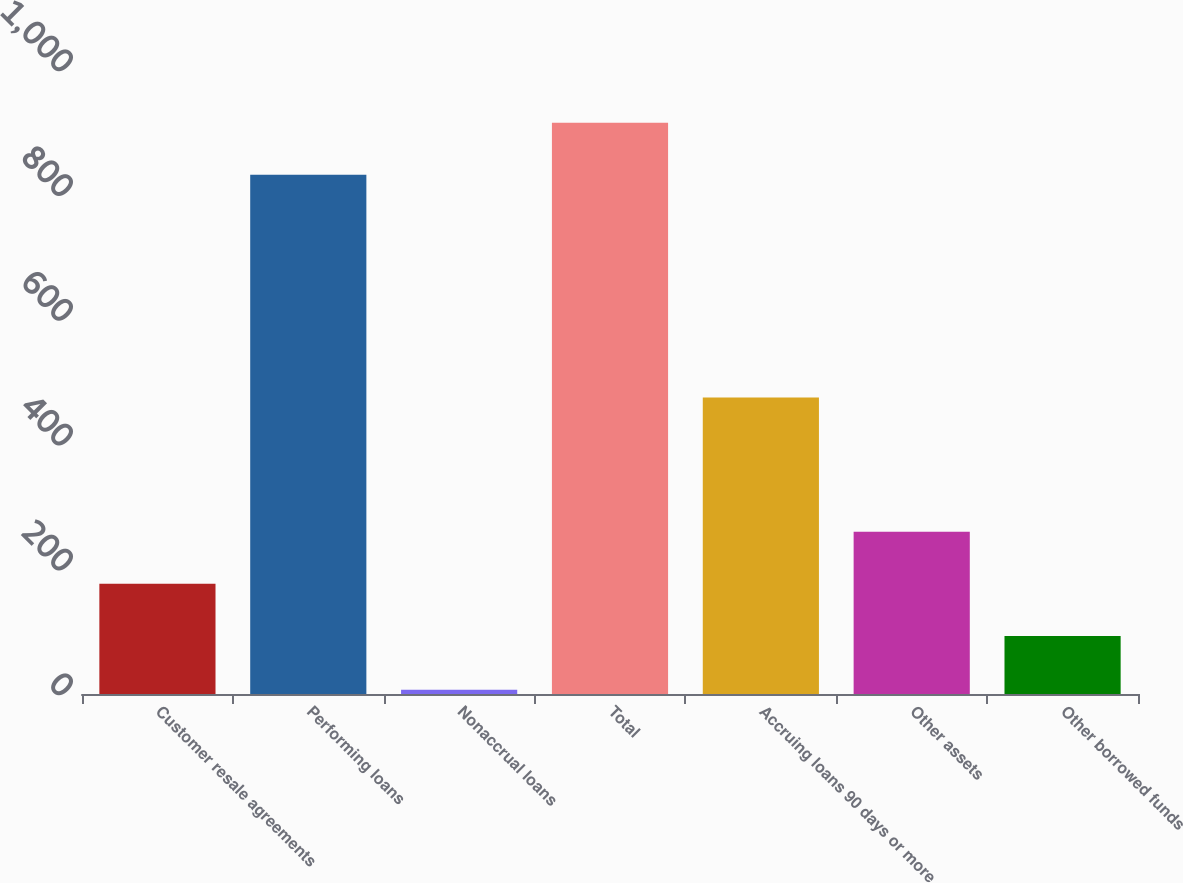Convert chart. <chart><loc_0><loc_0><loc_500><loc_500><bar_chart><fcel>Customer resale agreements<fcel>Performing loans<fcel>Nonaccrual loans<fcel>Total<fcel>Accruing loans 90 days or more<fcel>Other assets<fcel>Other borrowed funds<nl><fcel>176.6<fcel>832<fcel>7<fcel>915.6<fcel>475<fcel>260.2<fcel>93<nl></chart> 